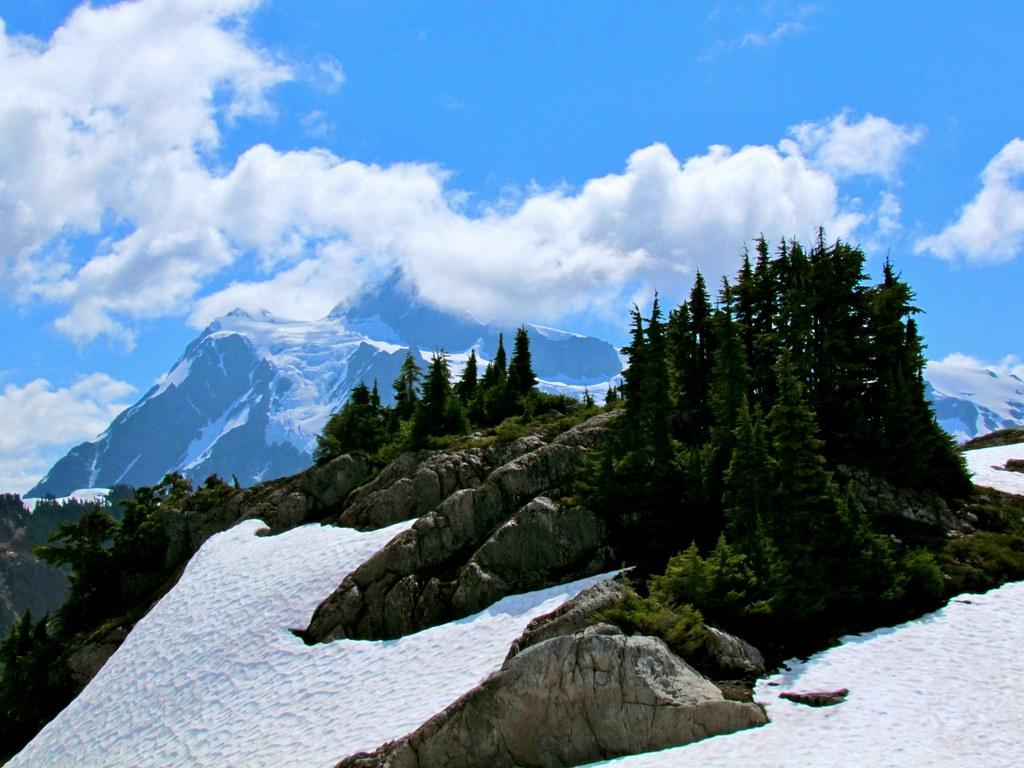What type of natural elements can be seen in the image? A: There are rocks, plants, and snow visible in the image. What type of vegetation is present in the image? There are plants and trees visible in the image. What can be seen in the background of the image? There are mountains and the sky visible in the background of the image. What news headline is being discussed by the rocks in the image? There are no rocks discussing news headlines in the image; they are simply natural elements in the scene. 